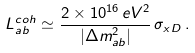<formula> <loc_0><loc_0><loc_500><loc_500>L ^ { c o h } _ { a b } \simeq \frac { 2 \times 1 0 ^ { 1 6 } \, e V ^ { 2 } } { | \Delta { m } ^ { 2 } _ { a b } | } \, \sigma _ { x D } \, .</formula> 